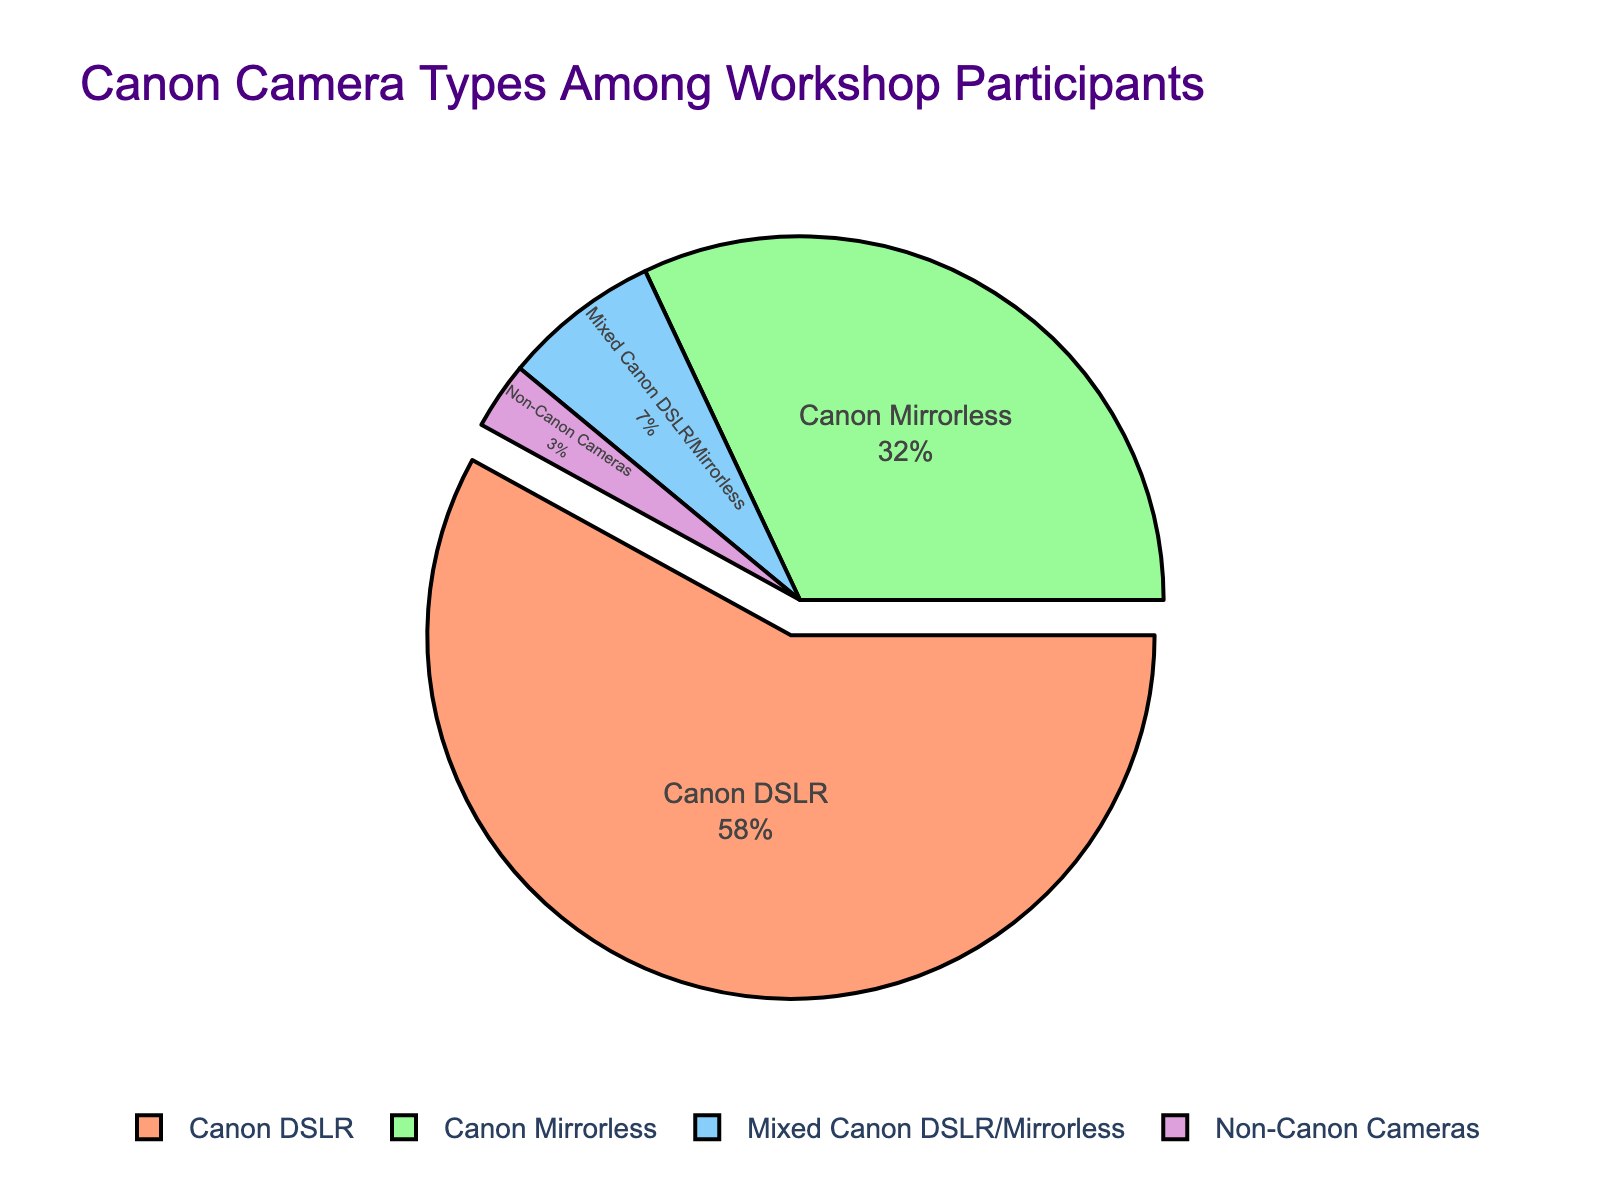What percentage of participants use both Canon DSLR and Mirrorless cameras? The pie chart indicates the various camera types and their respective percentages among workshop participants. The segment labeled "Mixed Canon DSLR/Mirrorless" shows 7%.
Answer: 7% How many times larger is the percentage of Canon DSLR users compared to Non-Canon camera users? The pie chart shows that Canon DSLR users are 58% and Non-Canon camera users are 3%. To find how many times larger, divide 58 by 3: \( \frac{58}{3} \approx 19.33 \).
Answer: About 19.33 times What is the total percentage of participants using Canon cameras (DSLR, Mirrorless, and Mixed)? Add the percentages of Canon DSLR users (58%), Canon Mirrorless users (32%), and Mixed users (7%): \( 58 + 32 + 7 = 97 \).
Answer: 97% Which camera type has the second largest segment, and what percentage does it represent? By visually examining the pie chart, the second largest segment is Canon Mirrorless, which represents 32%.
Answer: Canon Mirrorless, 32% What percentage of participants do not use Canon cameras? The slice labeled "Non-Canon Cameras" represents the percentage of participants using non-Canon cameras, which is shown as 3%.
Answer: 3% If the pie chart were rotated so that the Canon DSLR segment starts at the top, which color would the next segment (Canon Mirrorless) be? The Canon DSLR segment has been pulled out and is typically the first in sequence. The next segment for Canon Mirrorless is green.
Answer: Green What is the difference in percentages between Canon DSLR users and Canon Mirrorless users? Subtract the percentage of Canon Mirrorless users (32%) from the percentage of Canon DSLR users (58%): \( 58 - 32 = 26 \).
Answer: 26% What fraction of the participants use a mix of Canon DSLR and Mirrorless cameras? The pie chart shows 7% of participants use both types of Canon cameras. To convert this to a fraction, \( \frac{7}{100} = \frac{7}{100} \).
Answer: 7/100 Which type of camera has the smallest representation among participants, and what is its percentage? The smallest segment is labeled "Non-Canon Cameras" and has a percentage of 3%.
Answer: Non-Canon Cameras, 3% How many camera types are listed on the pie chart? By counting the distinct labeled segments on the pie chart, there are four camera types listed: Canon DSLR, Canon Mirrorless, Mixed Canon DSLR/Mirrorless, and Non-Canon Cameras.
Answer: 4 